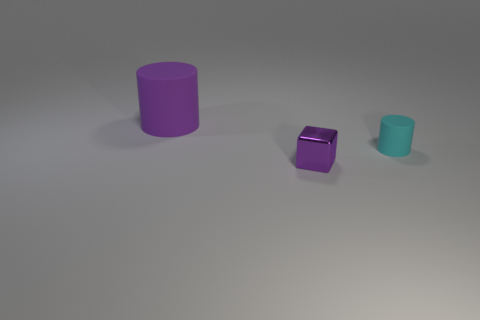How many other things are the same shape as the purple matte object?
Your answer should be very brief. 1. Do the purple rubber object and the tiny purple metal thing have the same shape?
Provide a short and direct response. No. The thing that is to the left of the small cyan object and in front of the big cylinder is what color?
Make the answer very short. Purple. There is a thing that is the same color as the block; what size is it?
Your answer should be very brief. Large. What number of small things are cyan things or purple matte objects?
Offer a terse response. 1. Are there any other things that have the same color as the tiny block?
Offer a terse response. Yes. There is a small object in front of the matte thing in front of the matte object behind the tiny cyan rubber object; what is it made of?
Your response must be concise. Metal. What number of metallic things are either spheres or small purple objects?
Offer a very short reply. 1. What number of red things are either big rubber things or small cubes?
Keep it short and to the point. 0. Is the color of the matte object that is in front of the big thing the same as the big object?
Provide a short and direct response. No. 